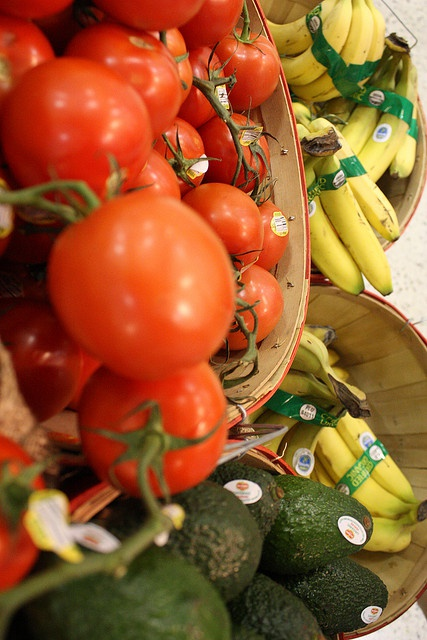Describe the objects in this image and their specific colors. I can see banana in maroon, khaki, gold, and olive tones, banana in maroon, khaki, darkgreen, and olive tones, banana in maroon, khaki, olive, and black tones, banana in maroon, gold, and olive tones, and banana in maroon, olive, and black tones in this image. 